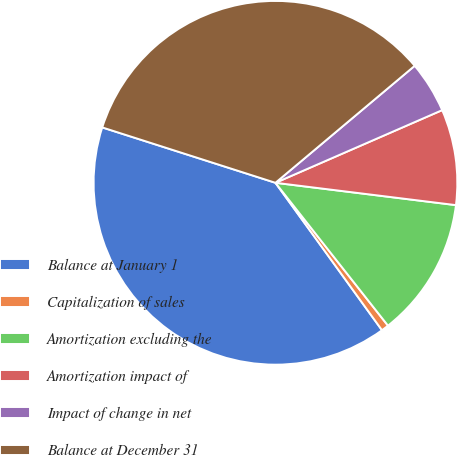Convert chart. <chart><loc_0><loc_0><loc_500><loc_500><pie_chart><fcel>Balance at January 1<fcel>Capitalization of sales<fcel>Amortization excluding the<fcel>Amortization impact of<fcel>Impact of change in net<fcel>Balance at December 31<nl><fcel>39.88%<fcel>0.66%<fcel>12.42%<fcel>8.5%<fcel>4.58%<fcel>33.95%<nl></chart> 